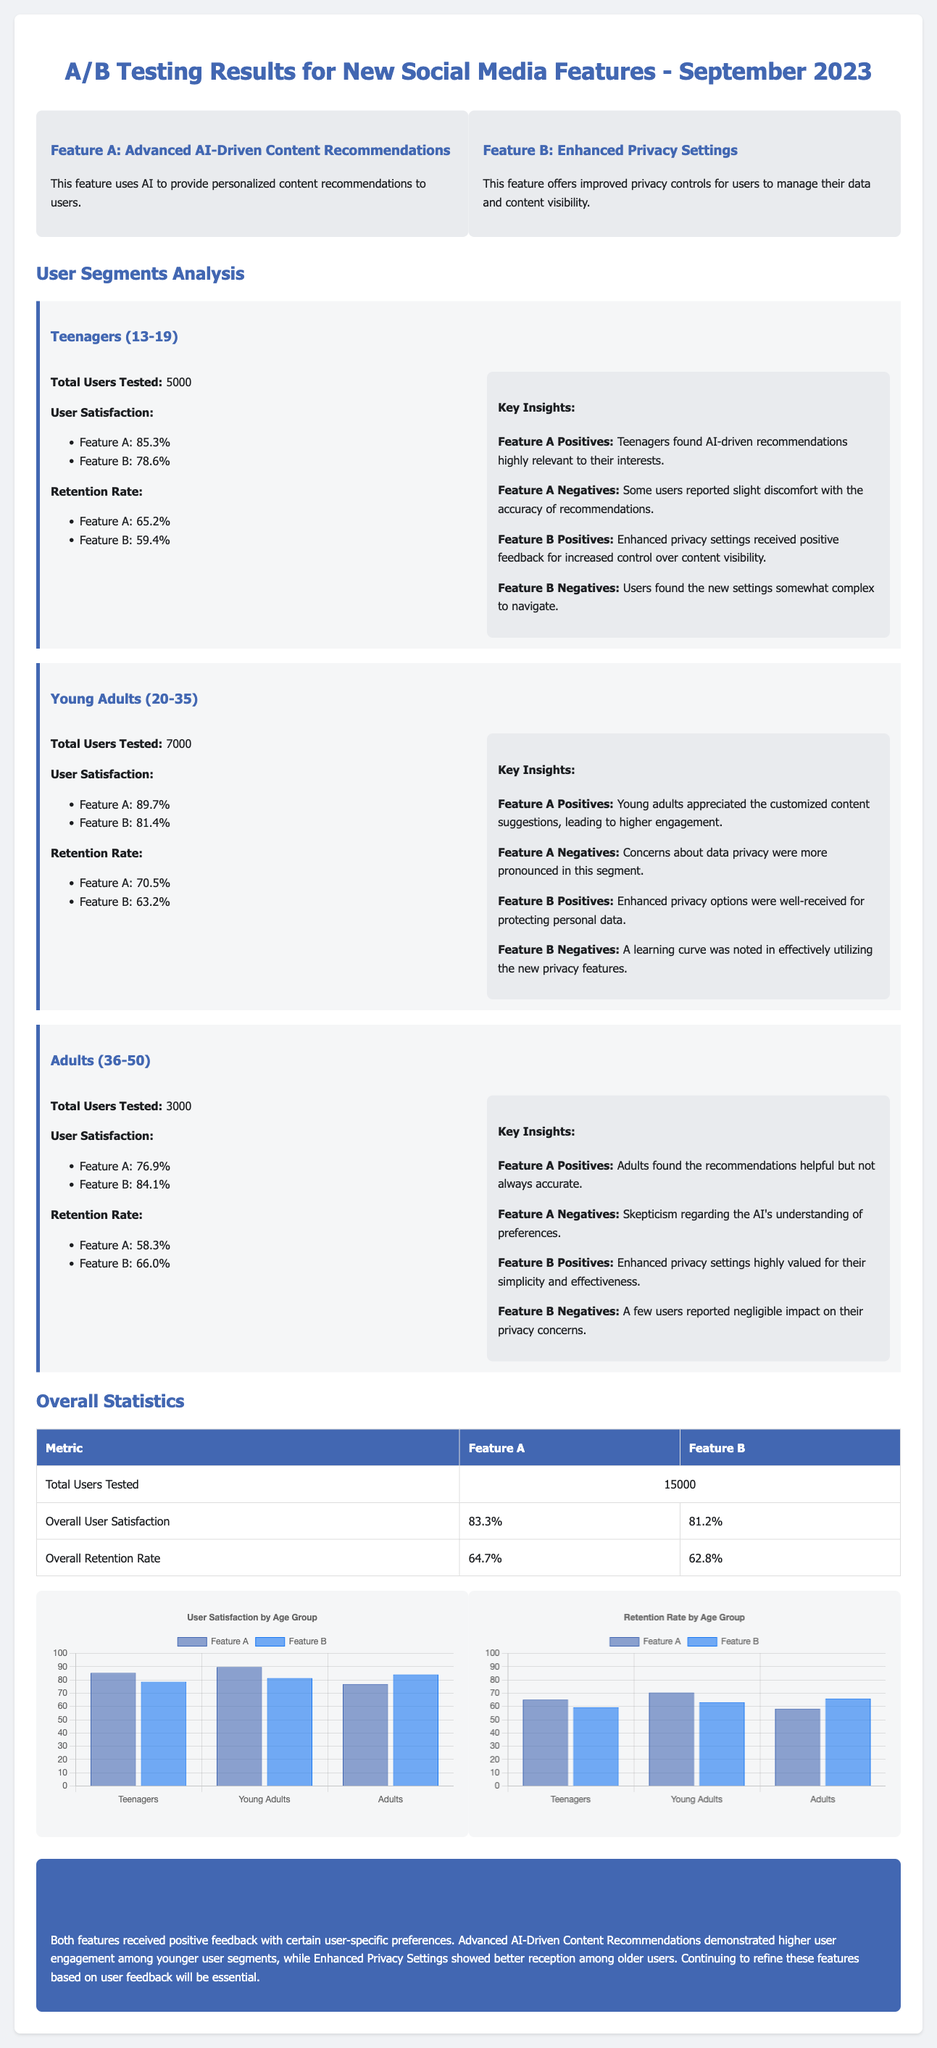what is the title of the document? The title of the document is stated in the header section as “A/B Testing Results for New Social Media Features - September 2023.”
Answer: A/B Testing Results for New Social Media Features - September 2023 how many total users were tested for Feature A? The total users tested for Feature A is given in the overall statistics table, which states it as 15,000 across all segments.
Answer: 15000 what is the user satisfaction rate for Feature B among Young Adults? The user satisfaction rate for Feature B among Young Adults is specified in the Young Adults segment, indicating an 81.4% satisfaction rate.
Answer: 81.4% which feature received higher user satisfaction overall? The overall user satisfaction section provides percentages for both features, where Feature A has 83.3% and Feature B has 81.2%, indicating Feature A is higher.
Answer: Feature A what percentage of teenagers reported user satisfaction with Feature A? The document states a user satisfaction for Feature A among Teenagers as 85.3% in the Teenagers segment.
Answer: 85.3% which user segment showed the highest retention rate for Feature A? Retention rates are listed for different user segments, where Young Adults show the highest retention rate for Feature A at 70.5%.
Answer: Young Adults what is a negative feedback noted for Feature B among Teenagers? The document states that users found the new settings somewhat complex to navigate, which is categorized as a negative for Feature B among Teenagers.
Answer: Complex to navigate how are the insights on Feature A for Adults summarized? The insights indicate that Adults found the recommendations helpful but not always accurate, which encapsulates their feedback on Feature A.
Answer: Helpful but not always accurate what conclusion does the document draw about user engagement among different features? The conclusion provides an overview of how both features performed, highlighting that Feature A demonstrated higher user engagement among younger user segments.
Answer: Higher user engagement among younger user segments 